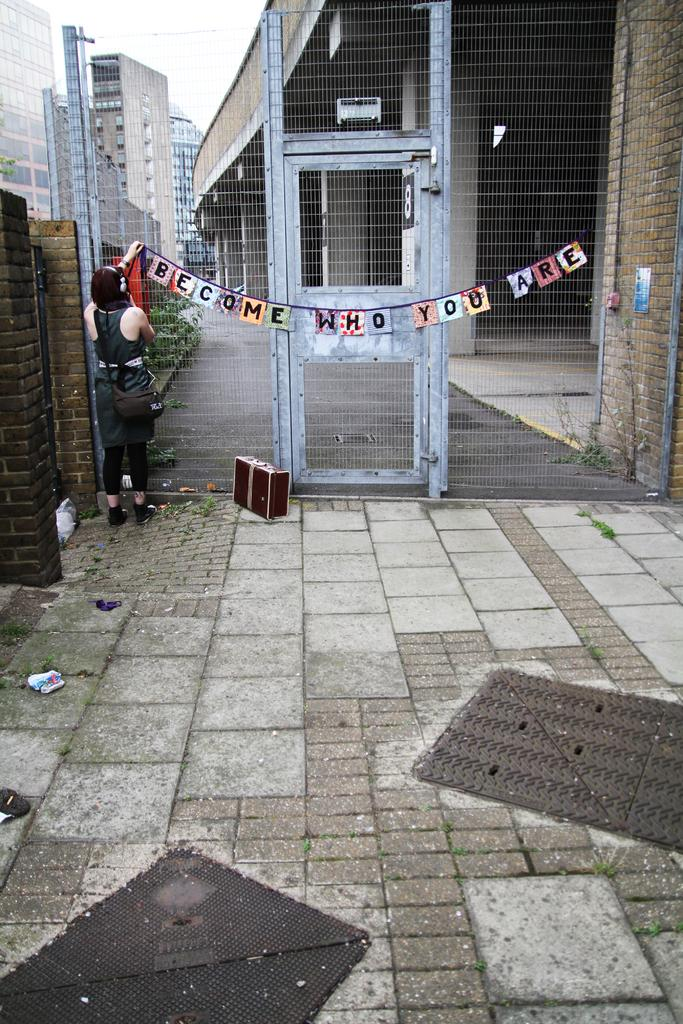<image>
Relay a brief, clear account of the picture shown. A locked high gate with a banner proclaiming 'Become who you are' draped across its door. 